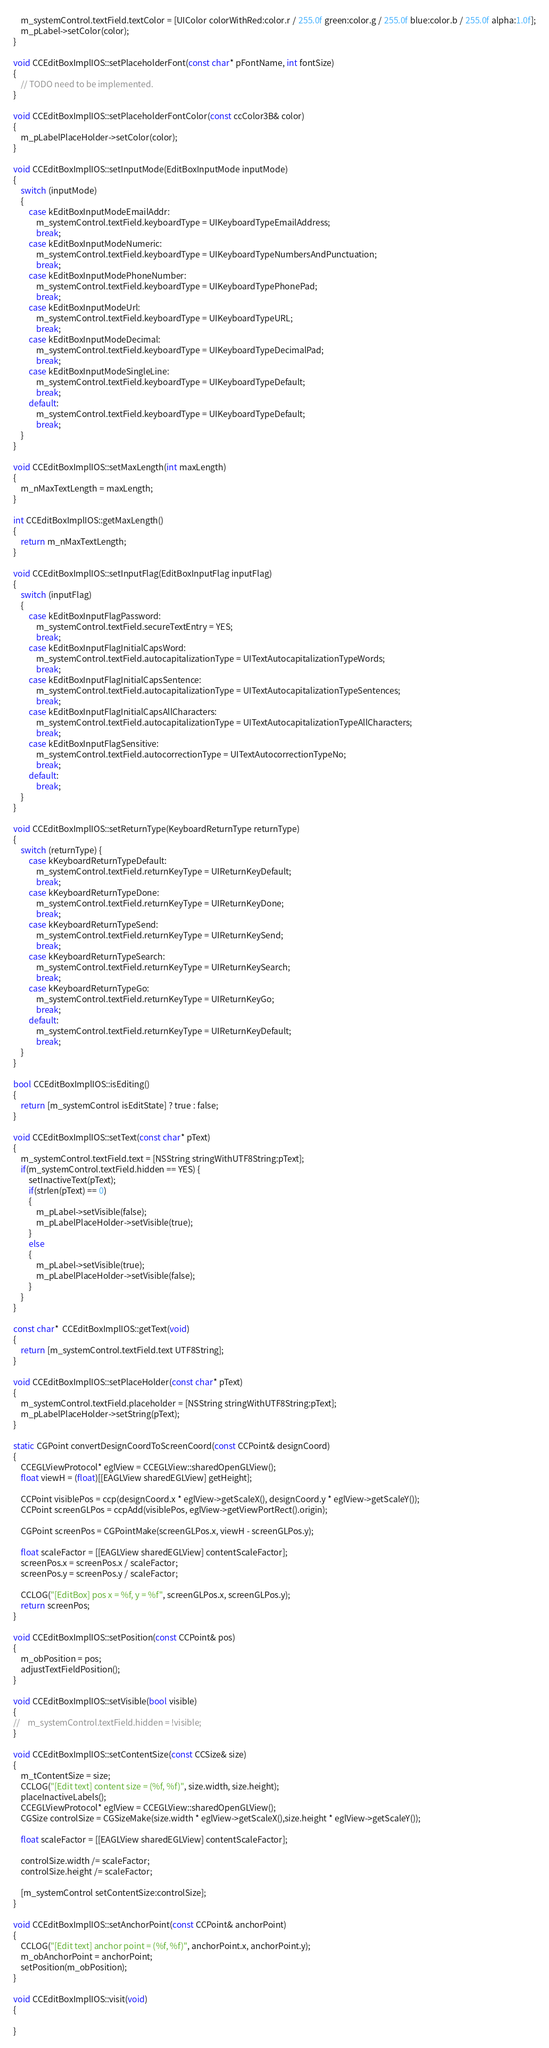<code> <loc_0><loc_0><loc_500><loc_500><_ObjectiveC_>    m_systemControl.textField.textColor = [UIColor colorWithRed:color.r / 255.0f green:color.g / 255.0f blue:color.b / 255.0f alpha:1.0f];
	m_pLabel->setColor(color);
}

void CCEditBoxImplIOS::setPlaceholderFont(const char* pFontName, int fontSize)
{
	// TODO need to be implemented.
}

void CCEditBoxImplIOS::setPlaceholderFontColor(const ccColor3B& color)
{
	m_pLabelPlaceHolder->setColor(color);
}

void CCEditBoxImplIOS::setInputMode(EditBoxInputMode inputMode)
{
    switch (inputMode)
    {
        case kEditBoxInputModeEmailAddr:
            m_systemControl.textField.keyboardType = UIKeyboardTypeEmailAddress;
            break;
        case kEditBoxInputModeNumeric:
            m_systemControl.textField.keyboardType = UIKeyboardTypeNumbersAndPunctuation;
            break;
        case kEditBoxInputModePhoneNumber:
            m_systemControl.textField.keyboardType = UIKeyboardTypePhonePad;
            break;
        case kEditBoxInputModeUrl:
            m_systemControl.textField.keyboardType = UIKeyboardTypeURL;
            break;
        case kEditBoxInputModeDecimal:
            m_systemControl.textField.keyboardType = UIKeyboardTypeDecimalPad;
            break;
        case kEditBoxInputModeSingleLine:
            m_systemControl.textField.keyboardType = UIKeyboardTypeDefault;
            break;
        default:
            m_systemControl.textField.keyboardType = UIKeyboardTypeDefault;
            break;
    }
}

void CCEditBoxImplIOS::setMaxLength(int maxLength)
{
    m_nMaxTextLength = maxLength;
}

int CCEditBoxImplIOS::getMaxLength()
{
    return m_nMaxTextLength;
}

void CCEditBoxImplIOS::setInputFlag(EditBoxInputFlag inputFlag)
{
    switch (inputFlag)
    {
        case kEditBoxInputFlagPassword:
            m_systemControl.textField.secureTextEntry = YES;
            break;
        case kEditBoxInputFlagInitialCapsWord:
            m_systemControl.textField.autocapitalizationType = UITextAutocapitalizationTypeWords;
            break;
        case kEditBoxInputFlagInitialCapsSentence:
            m_systemControl.textField.autocapitalizationType = UITextAutocapitalizationTypeSentences;
            break;
        case kEditBoxInputFlagInitialCapsAllCharacters:
            m_systemControl.textField.autocapitalizationType = UITextAutocapitalizationTypeAllCharacters;
            break;
        case kEditBoxInputFlagSensitive:
            m_systemControl.textField.autocorrectionType = UITextAutocorrectionTypeNo;
            break;
        default:
            break;
    }
}

void CCEditBoxImplIOS::setReturnType(KeyboardReturnType returnType)
{
    switch (returnType) {
        case kKeyboardReturnTypeDefault:
            m_systemControl.textField.returnKeyType = UIReturnKeyDefault;
            break;
        case kKeyboardReturnTypeDone:
            m_systemControl.textField.returnKeyType = UIReturnKeyDone;
            break;
        case kKeyboardReturnTypeSend:
            m_systemControl.textField.returnKeyType = UIReturnKeySend;
            break;
        case kKeyboardReturnTypeSearch:
            m_systemControl.textField.returnKeyType = UIReturnKeySearch;
            break;
        case kKeyboardReturnTypeGo:
            m_systemControl.textField.returnKeyType = UIReturnKeyGo;
            break;
        default:
            m_systemControl.textField.returnKeyType = UIReturnKeyDefault;
            break;
    }
}

bool CCEditBoxImplIOS::isEditing()
{
    return [m_systemControl isEditState] ? true : false;
}

void CCEditBoxImplIOS::setText(const char* pText)
{
    m_systemControl.textField.text = [NSString stringWithUTF8String:pText];
	if(m_systemControl.textField.hidden == YES) {
		setInactiveText(pText);
		if(strlen(pText) == 0)
		{
			m_pLabel->setVisible(false);
			m_pLabelPlaceHolder->setVisible(true);
		}
		else
		{
			m_pLabel->setVisible(true);
			m_pLabelPlaceHolder->setVisible(false);
		}
	}
}

const char*  CCEditBoxImplIOS::getText(void)
{
    return [m_systemControl.textField.text UTF8String];
}

void CCEditBoxImplIOS::setPlaceHolder(const char* pText)
{
    m_systemControl.textField.placeholder = [NSString stringWithUTF8String:pText];
	m_pLabelPlaceHolder->setString(pText);
}

static CGPoint convertDesignCoordToScreenCoord(const CCPoint& designCoord)
{
    CCEGLViewProtocol* eglView = CCEGLView::sharedOpenGLView();
    float viewH = (float)[[EAGLView sharedEGLView] getHeight];
    
    CCPoint visiblePos = ccp(designCoord.x * eglView->getScaleX(), designCoord.y * eglView->getScaleY());
    CCPoint screenGLPos = ccpAdd(visiblePos, eglView->getViewPortRect().origin);
    
    CGPoint screenPos = CGPointMake(screenGLPos.x, viewH - screenGLPos.y);
    
    float scaleFactor = [[EAGLView sharedEGLView] contentScaleFactor];
    screenPos.x = screenPos.x / scaleFactor;
    screenPos.y = screenPos.y / scaleFactor;
    
    CCLOG("[EditBox] pos x = %f, y = %f", screenGLPos.x, screenGLPos.y);
    return screenPos;
}

void CCEditBoxImplIOS::setPosition(const CCPoint& pos)
{
	m_obPosition = pos;
	adjustTextFieldPosition();
}

void CCEditBoxImplIOS::setVisible(bool visible)
{
//    m_systemControl.textField.hidden = !visible;
}

void CCEditBoxImplIOS::setContentSize(const CCSize& size)
{
    m_tContentSize = size;
    CCLOG("[Edit text] content size = (%f, %f)", size.width, size.height);
    placeInactiveLabels();
    CCEGLViewProtocol* eglView = CCEGLView::sharedOpenGLView();
    CGSize controlSize = CGSizeMake(size.width * eglView->getScaleX(),size.height * eglView->getScaleY());
    
    float scaleFactor = [[EAGLView sharedEGLView] contentScaleFactor];
    
    controlSize.width /= scaleFactor;
    controlSize.height /= scaleFactor;

    [m_systemControl setContentSize:controlSize];
}

void CCEditBoxImplIOS::setAnchorPoint(const CCPoint& anchorPoint)
{
    CCLOG("[Edit text] anchor point = (%f, %f)", anchorPoint.x, anchorPoint.y);
	m_obAnchorPoint = anchorPoint;
	setPosition(m_obPosition);
}

void CCEditBoxImplIOS::visit(void)
{
    
}
</code> 